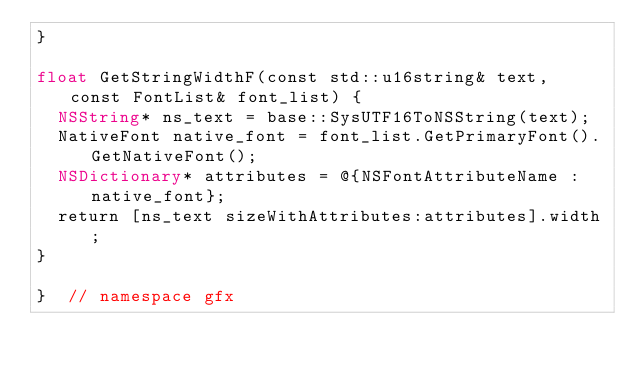<code> <loc_0><loc_0><loc_500><loc_500><_ObjectiveC_>}

float GetStringWidthF(const std::u16string& text, const FontList& font_list) {
  NSString* ns_text = base::SysUTF16ToNSString(text);
  NativeFont native_font = font_list.GetPrimaryFont().GetNativeFont();
  NSDictionary* attributes = @{NSFontAttributeName : native_font};
  return [ns_text sizeWithAttributes:attributes].width;
}

}  // namespace gfx
</code> 